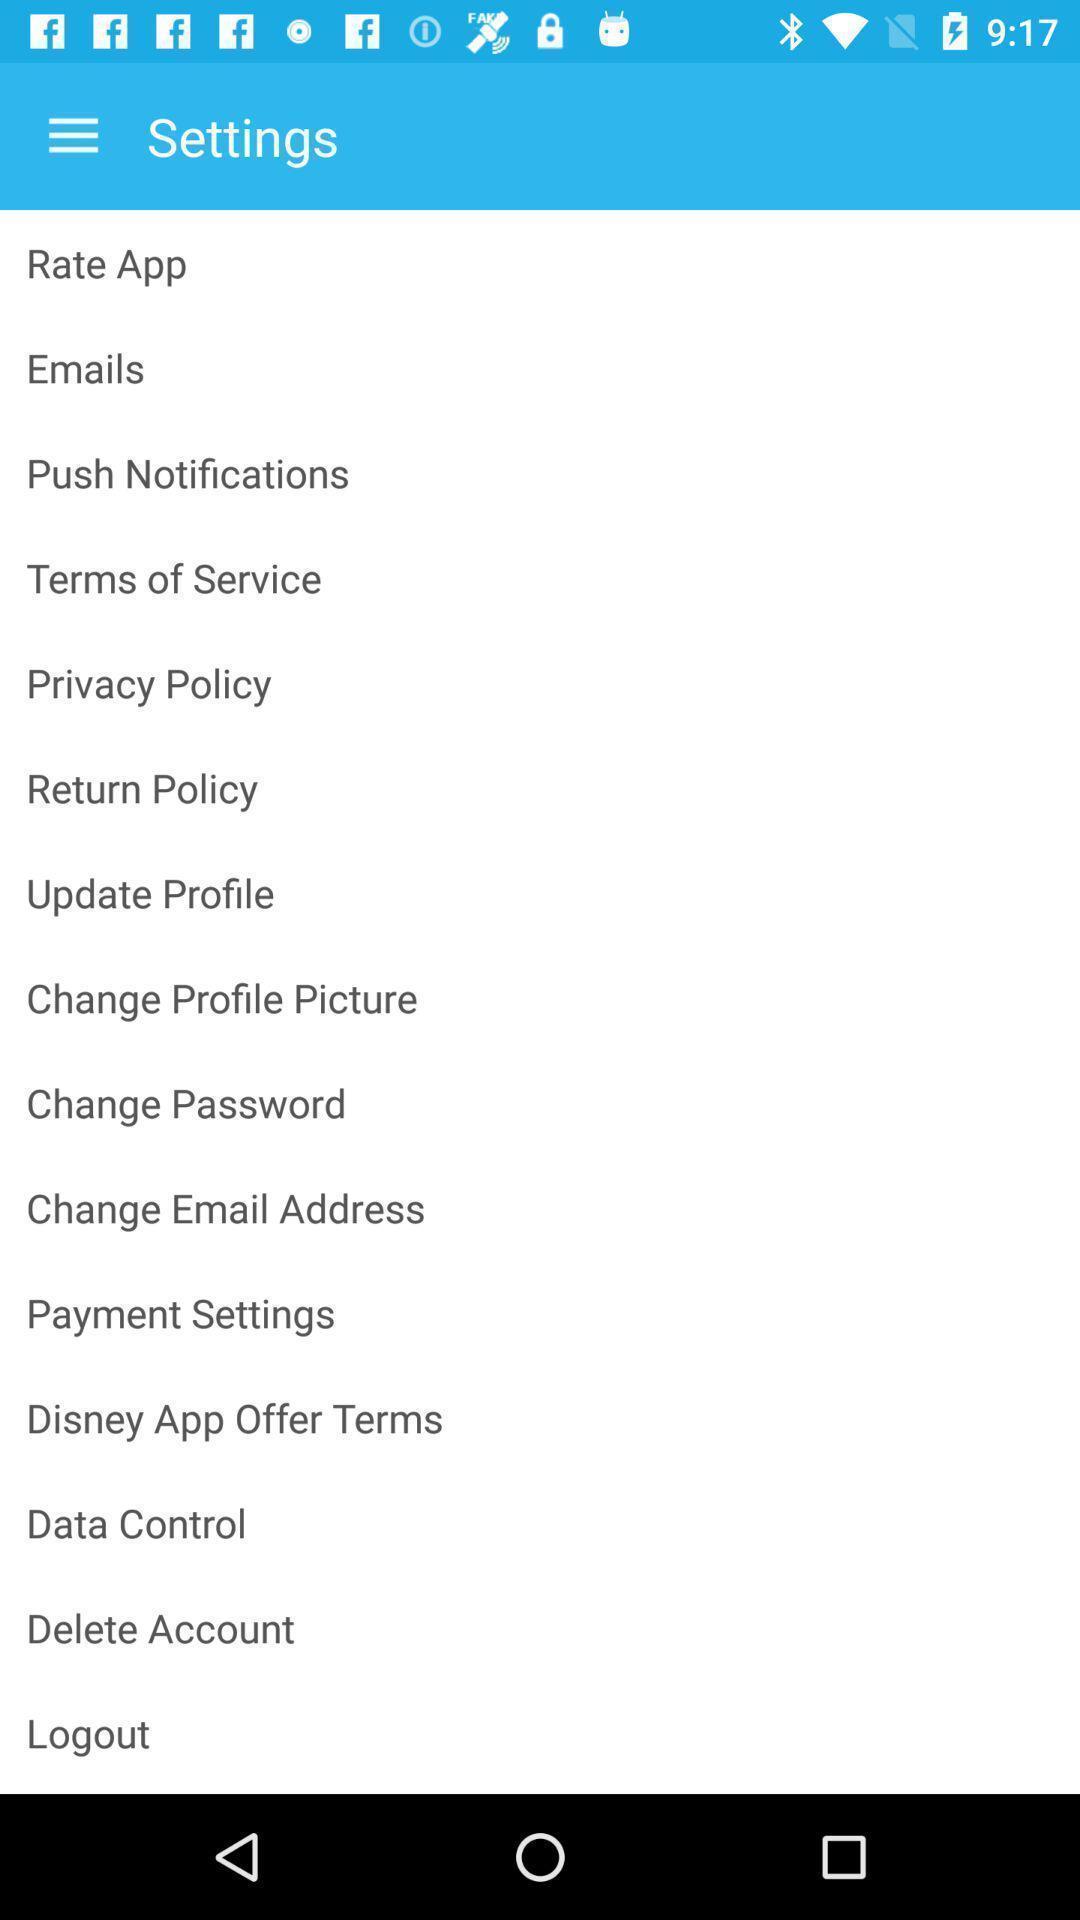What can you discern from this picture? Screen showing settings page. 